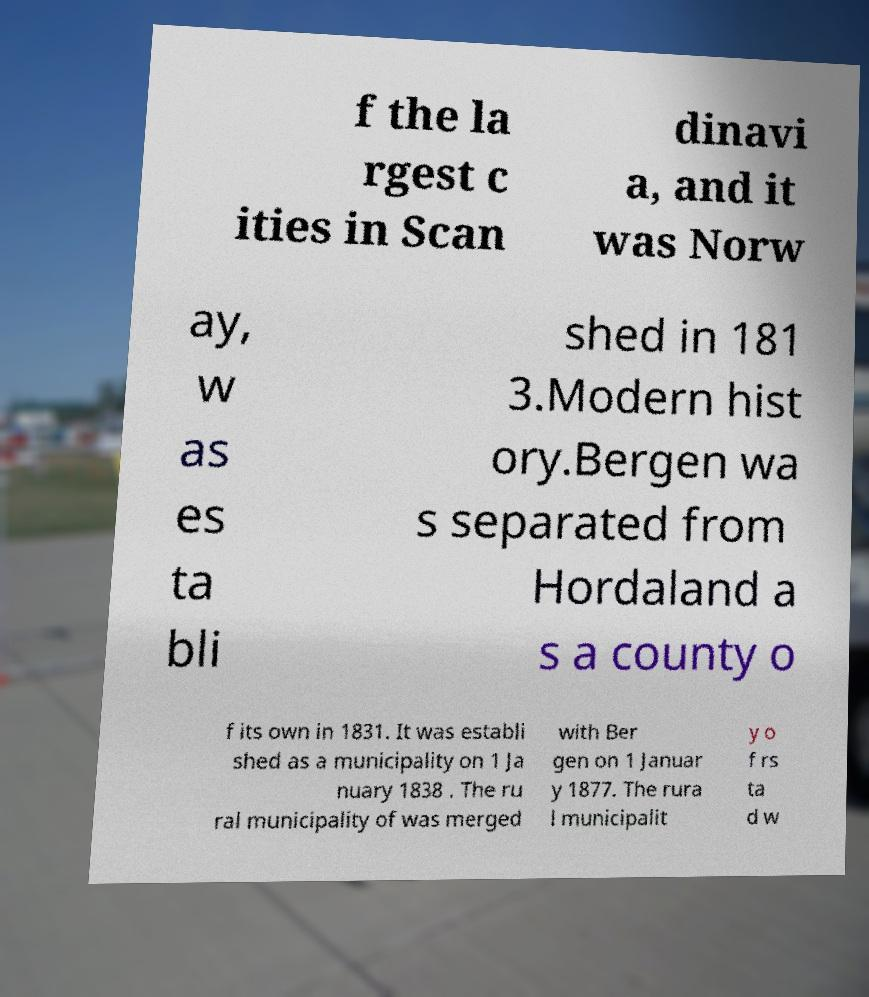Could you extract and type out the text from this image? f the la rgest c ities in Scan dinavi a, and it was Norw ay, w as es ta bli shed in 181 3.Modern hist ory.Bergen wa s separated from Hordaland a s a county o f its own in 1831. It was establi shed as a municipality on 1 Ja nuary 1838 . The ru ral municipality of was merged with Ber gen on 1 Januar y 1877. The rura l municipalit y o f rs ta d w 